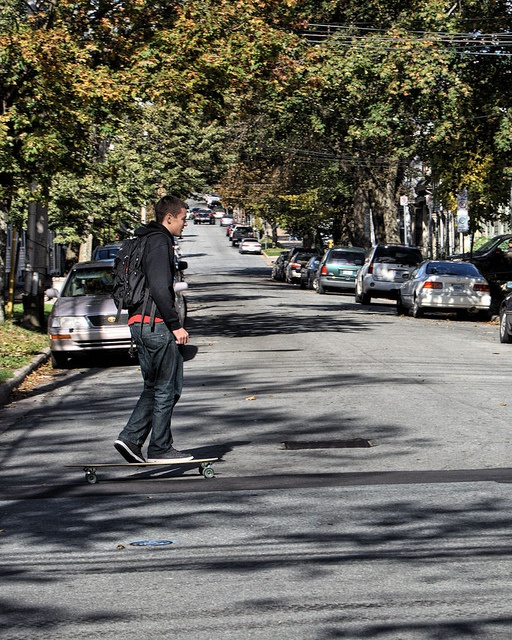Describe the objects in this image and their specific colors. I can see people in olive, black, gray, and darkblue tones, car in olive, black, gray, lightgray, and darkgray tones, car in olive, black, gray, darkgray, and lightgray tones, car in olive, black, darkgray, gray, and lightgray tones, and car in olive, black, gray, darkgray, and lightgray tones in this image. 